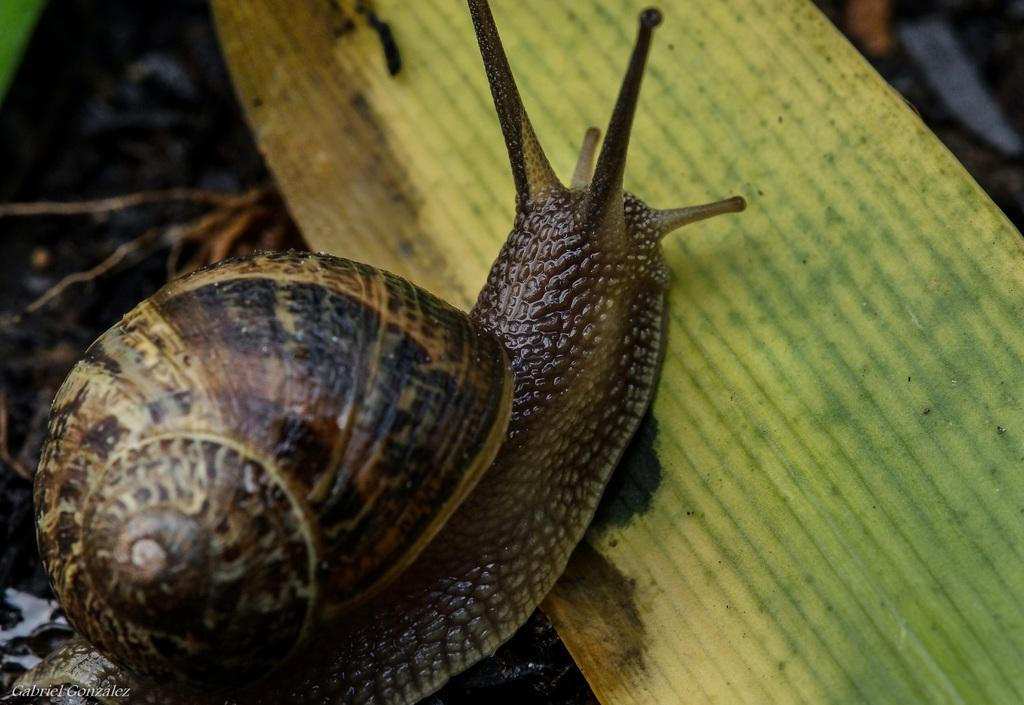What is the main subject of the image? There is a snail in the image. What is the snail doing in the image? The snail is walking on a green leaf. What color is the snail? The snail is brown in color. What arithmetic problem is the snail solving on the green leaf? There is no arithmetic problem present in the image; it features a snail walking on a green leaf. Is there a pipe visible in the image? No, there is no pipe present in the image. 